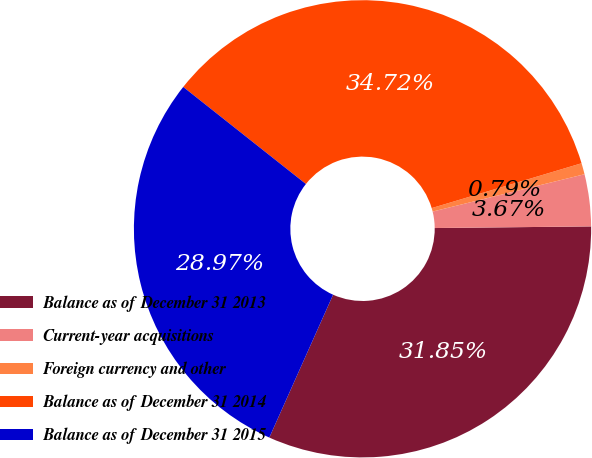<chart> <loc_0><loc_0><loc_500><loc_500><pie_chart><fcel>Balance as of December 31 2013<fcel>Current-year acquisitions<fcel>Foreign currency and other<fcel>Balance as of December 31 2014<fcel>Balance as of December 31 2015<nl><fcel>31.85%<fcel>3.67%<fcel>0.79%<fcel>34.72%<fcel>28.97%<nl></chart> 